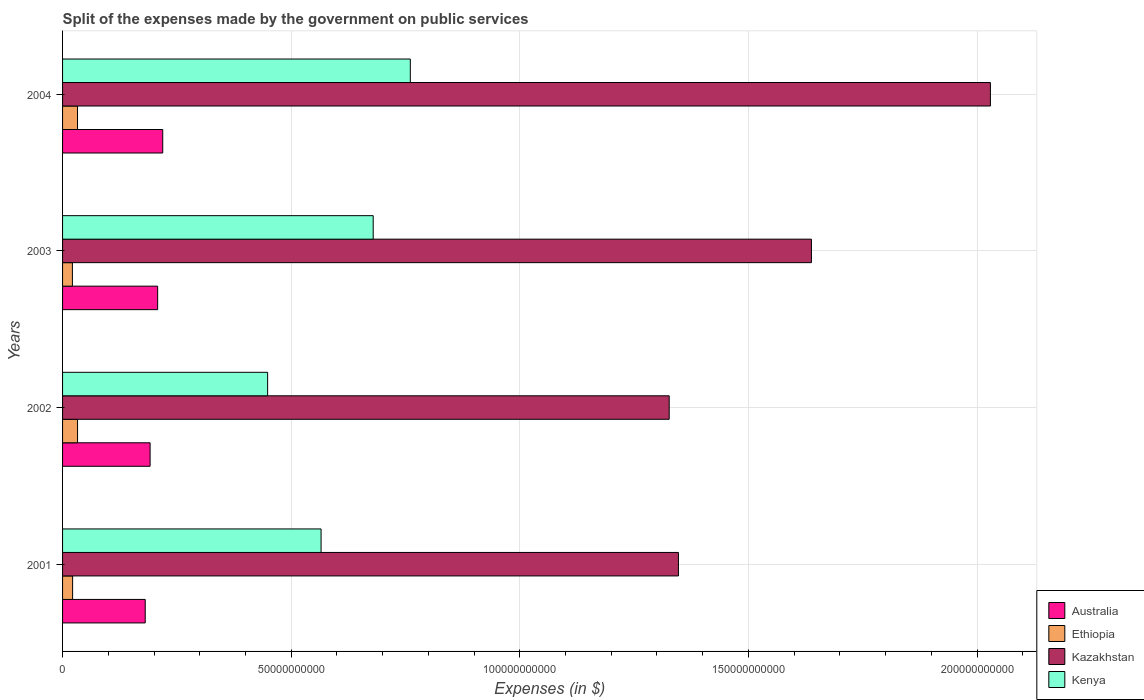How many different coloured bars are there?
Keep it short and to the point. 4. How many groups of bars are there?
Offer a very short reply. 4. Are the number of bars per tick equal to the number of legend labels?
Give a very brief answer. Yes. Are the number of bars on each tick of the Y-axis equal?
Offer a terse response. Yes. What is the expenses made by the government on public services in Australia in 2002?
Your answer should be very brief. 1.91e+1. Across all years, what is the maximum expenses made by the government on public services in Kazakhstan?
Ensure brevity in your answer.  2.03e+11. Across all years, what is the minimum expenses made by the government on public services in Kazakhstan?
Ensure brevity in your answer.  1.33e+11. In which year was the expenses made by the government on public services in Kazakhstan maximum?
Your answer should be very brief. 2004. In which year was the expenses made by the government on public services in Ethiopia minimum?
Your answer should be compact. 2003. What is the total expenses made by the government on public services in Ethiopia in the graph?
Offer a terse response. 1.09e+1. What is the difference between the expenses made by the government on public services in Kenya in 2001 and that in 2002?
Offer a terse response. 1.17e+1. What is the difference between the expenses made by the government on public services in Australia in 2003 and the expenses made by the government on public services in Kazakhstan in 2002?
Give a very brief answer. -1.12e+11. What is the average expenses made by the government on public services in Australia per year?
Provide a succinct answer. 2.00e+1. In the year 2001, what is the difference between the expenses made by the government on public services in Australia and expenses made by the government on public services in Kazakhstan?
Keep it short and to the point. -1.17e+11. What is the ratio of the expenses made by the government on public services in Ethiopia in 2003 to that in 2004?
Keep it short and to the point. 0.66. Is the expenses made by the government on public services in Ethiopia in 2001 less than that in 2003?
Keep it short and to the point. No. Is the difference between the expenses made by the government on public services in Australia in 2001 and 2003 greater than the difference between the expenses made by the government on public services in Kazakhstan in 2001 and 2003?
Your answer should be very brief. Yes. What is the difference between the highest and the second highest expenses made by the government on public services in Kenya?
Offer a terse response. 8.12e+09. What is the difference between the highest and the lowest expenses made by the government on public services in Australia?
Give a very brief answer. 3.83e+09. In how many years, is the expenses made by the government on public services in Australia greater than the average expenses made by the government on public services in Australia taken over all years?
Give a very brief answer. 2. Is the sum of the expenses made by the government on public services in Kazakhstan in 2002 and 2003 greater than the maximum expenses made by the government on public services in Ethiopia across all years?
Offer a very short reply. Yes. Is it the case that in every year, the sum of the expenses made by the government on public services in Australia and expenses made by the government on public services in Kazakhstan is greater than the sum of expenses made by the government on public services in Ethiopia and expenses made by the government on public services in Kenya?
Your answer should be compact. No. What does the 3rd bar from the top in 2004 represents?
Provide a short and direct response. Ethiopia. What does the 3rd bar from the bottom in 2004 represents?
Provide a succinct answer. Kazakhstan. How many bars are there?
Provide a short and direct response. 16. Are all the bars in the graph horizontal?
Ensure brevity in your answer.  Yes. How many years are there in the graph?
Provide a short and direct response. 4. Where does the legend appear in the graph?
Keep it short and to the point. Bottom right. What is the title of the graph?
Make the answer very short. Split of the expenses made by the government on public services. What is the label or title of the X-axis?
Make the answer very short. Expenses (in $). What is the Expenses (in $) in Australia in 2001?
Keep it short and to the point. 1.81e+1. What is the Expenses (in $) of Ethiopia in 2001?
Keep it short and to the point. 2.20e+09. What is the Expenses (in $) in Kazakhstan in 2001?
Ensure brevity in your answer.  1.35e+11. What is the Expenses (in $) in Kenya in 2001?
Offer a terse response. 5.65e+1. What is the Expenses (in $) of Australia in 2002?
Offer a terse response. 1.91e+1. What is the Expenses (in $) in Ethiopia in 2002?
Your response must be concise. 3.28e+09. What is the Expenses (in $) in Kazakhstan in 2002?
Your response must be concise. 1.33e+11. What is the Expenses (in $) of Kenya in 2002?
Your answer should be very brief. 4.49e+1. What is the Expenses (in $) in Australia in 2003?
Provide a short and direct response. 2.08e+1. What is the Expenses (in $) in Ethiopia in 2003?
Give a very brief answer. 2.15e+09. What is the Expenses (in $) of Kazakhstan in 2003?
Keep it short and to the point. 1.64e+11. What is the Expenses (in $) of Kenya in 2003?
Provide a succinct answer. 6.79e+1. What is the Expenses (in $) of Australia in 2004?
Provide a short and direct response. 2.19e+1. What is the Expenses (in $) in Ethiopia in 2004?
Make the answer very short. 3.27e+09. What is the Expenses (in $) in Kazakhstan in 2004?
Provide a succinct answer. 2.03e+11. What is the Expenses (in $) of Kenya in 2004?
Provide a short and direct response. 7.61e+1. Across all years, what is the maximum Expenses (in $) in Australia?
Provide a succinct answer. 2.19e+1. Across all years, what is the maximum Expenses (in $) of Ethiopia?
Give a very brief answer. 3.28e+09. Across all years, what is the maximum Expenses (in $) in Kazakhstan?
Offer a very short reply. 2.03e+11. Across all years, what is the maximum Expenses (in $) of Kenya?
Ensure brevity in your answer.  7.61e+1. Across all years, what is the minimum Expenses (in $) in Australia?
Make the answer very short. 1.81e+1. Across all years, what is the minimum Expenses (in $) in Ethiopia?
Make the answer very short. 2.15e+09. Across all years, what is the minimum Expenses (in $) in Kazakhstan?
Your response must be concise. 1.33e+11. Across all years, what is the minimum Expenses (in $) of Kenya?
Give a very brief answer. 4.49e+1. What is the total Expenses (in $) in Australia in the graph?
Provide a succinct answer. 7.99e+1. What is the total Expenses (in $) in Ethiopia in the graph?
Give a very brief answer. 1.09e+1. What is the total Expenses (in $) in Kazakhstan in the graph?
Provide a succinct answer. 6.34e+11. What is the total Expenses (in $) of Kenya in the graph?
Ensure brevity in your answer.  2.45e+11. What is the difference between the Expenses (in $) in Australia in 2001 and that in 2002?
Ensure brevity in your answer.  -1.06e+09. What is the difference between the Expenses (in $) in Ethiopia in 2001 and that in 2002?
Offer a very short reply. -1.08e+09. What is the difference between the Expenses (in $) in Kazakhstan in 2001 and that in 2002?
Ensure brevity in your answer.  2.02e+09. What is the difference between the Expenses (in $) in Kenya in 2001 and that in 2002?
Your answer should be compact. 1.17e+1. What is the difference between the Expenses (in $) of Australia in 2001 and that in 2003?
Keep it short and to the point. -2.72e+09. What is the difference between the Expenses (in $) in Ethiopia in 2001 and that in 2003?
Give a very brief answer. 4.57e+07. What is the difference between the Expenses (in $) in Kazakhstan in 2001 and that in 2003?
Provide a succinct answer. -2.91e+1. What is the difference between the Expenses (in $) in Kenya in 2001 and that in 2003?
Your response must be concise. -1.14e+1. What is the difference between the Expenses (in $) in Australia in 2001 and that in 2004?
Your answer should be compact. -3.83e+09. What is the difference between the Expenses (in $) of Ethiopia in 2001 and that in 2004?
Your answer should be very brief. -1.07e+09. What is the difference between the Expenses (in $) in Kazakhstan in 2001 and that in 2004?
Ensure brevity in your answer.  -6.82e+1. What is the difference between the Expenses (in $) in Kenya in 2001 and that in 2004?
Make the answer very short. -1.95e+1. What is the difference between the Expenses (in $) in Australia in 2002 and that in 2003?
Your response must be concise. -1.66e+09. What is the difference between the Expenses (in $) of Ethiopia in 2002 and that in 2003?
Keep it short and to the point. 1.13e+09. What is the difference between the Expenses (in $) of Kazakhstan in 2002 and that in 2003?
Give a very brief answer. -3.11e+1. What is the difference between the Expenses (in $) of Kenya in 2002 and that in 2003?
Offer a terse response. -2.31e+1. What is the difference between the Expenses (in $) of Australia in 2002 and that in 2004?
Offer a terse response. -2.77e+09. What is the difference between the Expenses (in $) in Ethiopia in 2002 and that in 2004?
Provide a succinct answer. 8.70e+06. What is the difference between the Expenses (in $) of Kazakhstan in 2002 and that in 2004?
Your answer should be compact. -7.03e+1. What is the difference between the Expenses (in $) of Kenya in 2002 and that in 2004?
Your response must be concise. -3.12e+1. What is the difference between the Expenses (in $) in Australia in 2003 and that in 2004?
Provide a short and direct response. -1.11e+09. What is the difference between the Expenses (in $) in Ethiopia in 2003 and that in 2004?
Provide a succinct answer. -1.12e+09. What is the difference between the Expenses (in $) of Kazakhstan in 2003 and that in 2004?
Your answer should be compact. -3.91e+1. What is the difference between the Expenses (in $) of Kenya in 2003 and that in 2004?
Provide a short and direct response. -8.12e+09. What is the difference between the Expenses (in $) of Australia in 2001 and the Expenses (in $) of Ethiopia in 2002?
Provide a short and direct response. 1.48e+1. What is the difference between the Expenses (in $) in Australia in 2001 and the Expenses (in $) in Kazakhstan in 2002?
Your response must be concise. -1.15e+11. What is the difference between the Expenses (in $) in Australia in 2001 and the Expenses (in $) in Kenya in 2002?
Provide a succinct answer. -2.68e+1. What is the difference between the Expenses (in $) of Ethiopia in 2001 and the Expenses (in $) of Kazakhstan in 2002?
Offer a terse response. -1.30e+11. What is the difference between the Expenses (in $) of Ethiopia in 2001 and the Expenses (in $) of Kenya in 2002?
Offer a terse response. -4.27e+1. What is the difference between the Expenses (in $) in Kazakhstan in 2001 and the Expenses (in $) in Kenya in 2002?
Provide a succinct answer. 8.98e+1. What is the difference between the Expenses (in $) of Australia in 2001 and the Expenses (in $) of Ethiopia in 2003?
Keep it short and to the point. 1.59e+1. What is the difference between the Expenses (in $) of Australia in 2001 and the Expenses (in $) of Kazakhstan in 2003?
Keep it short and to the point. -1.46e+11. What is the difference between the Expenses (in $) of Australia in 2001 and the Expenses (in $) of Kenya in 2003?
Offer a terse response. -4.99e+1. What is the difference between the Expenses (in $) in Ethiopia in 2001 and the Expenses (in $) in Kazakhstan in 2003?
Your answer should be very brief. -1.62e+11. What is the difference between the Expenses (in $) in Ethiopia in 2001 and the Expenses (in $) in Kenya in 2003?
Your answer should be compact. -6.57e+1. What is the difference between the Expenses (in $) in Kazakhstan in 2001 and the Expenses (in $) in Kenya in 2003?
Make the answer very short. 6.68e+1. What is the difference between the Expenses (in $) in Australia in 2001 and the Expenses (in $) in Ethiopia in 2004?
Offer a terse response. 1.48e+1. What is the difference between the Expenses (in $) in Australia in 2001 and the Expenses (in $) in Kazakhstan in 2004?
Ensure brevity in your answer.  -1.85e+11. What is the difference between the Expenses (in $) in Australia in 2001 and the Expenses (in $) in Kenya in 2004?
Keep it short and to the point. -5.80e+1. What is the difference between the Expenses (in $) of Ethiopia in 2001 and the Expenses (in $) of Kazakhstan in 2004?
Your response must be concise. -2.01e+11. What is the difference between the Expenses (in $) in Ethiopia in 2001 and the Expenses (in $) in Kenya in 2004?
Keep it short and to the point. -7.39e+1. What is the difference between the Expenses (in $) in Kazakhstan in 2001 and the Expenses (in $) in Kenya in 2004?
Keep it short and to the point. 5.86e+1. What is the difference between the Expenses (in $) in Australia in 2002 and the Expenses (in $) in Ethiopia in 2003?
Ensure brevity in your answer.  1.70e+1. What is the difference between the Expenses (in $) of Australia in 2002 and the Expenses (in $) of Kazakhstan in 2003?
Your answer should be very brief. -1.45e+11. What is the difference between the Expenses (in $) in Australia in 2002 and the Expenses (in $) in Kenya in 2003?
Provide a short and direct response. -4.88e+1. What is the difference between the Expenses (in $) of Ethiopia in 2002 and the Expenses (in $) of Kazakhstan in 2003?
Offer a very short reply. -1.61e+11. What is the difference between the Expenses (in $) in Ethiopia in 2002 and the Expenses (in $) in Kenya in 2003?
Offer a terse response. -6.47e+1. What is the difference between the Expenses (in $) in Kazakhstan in 2002 and the Expenses (in $) in Kenya in 2003?
Ensure brevity in your answer.  6.47e+1. What is the difference between the Expenses (in $) in Australia in 2002 and the Expenses (in $) in Ethiopia in 2004?
Offer a terse response. 1.59e+1. What is the difference between the Expenses (in $) in Australia in 2002 and the Expenses (in $) in Kazakhstan in 2004?
Offer a very short reply. -1.84e+11. What is the difference between the Expenses (in $) of Australia in 2002 and the Expenses (in $) of Kenya in 2004?
Offer a very short reply. -5.69e+1. What is the difference between the Expenses (in $) of Ethiopia in 2002 and the Expenses (in $) of Kazakhstan in 2004?
Your response must be concise. -2.00e+11. What is the difference between the Expenses (in $) of Ethiopia in 2002 and the Expenses (in $) of Kenya in 2004?
Provide a short and direct response. -7.28e+1. What is the difference between the Expenses (in $) in Kazakhstan in 2002 and the Expenses (in $) in Kenya in 2004?
Provide a succinct answer. 5.66e+1. What is the difference between the Expenses (in $) of Australia in 2003 and the Expenses (in $) of Ethiopia in 2004?
Offer a very short reply. 1.75e+1. What is the difference between the Expenses (in $) of Australia in 2003 and the Expenses (in $) of Kazakhstan in 2004?
Offer a very short reply. -1.82e+11. What is the difference between the Expenses (in $) of Australia in 2003 and the Expenses (in $) of Kenya in 2004?
Offer a terse response. -5.53e+1. What is the difference between the Expenses (in $) of Ethiopia in 2003 and the Expenses (in $) of Kazakhstan in 2004?
Ensure brevity in your answer.  -2.01e+11. What is the difference between the Expenses (in $) of Ethiopia in 2003 and the Expenses (in $) of Kenya in 2004?
Ensure brevity in your answer.  -7.39e+1. What is the difference between the Expenses (in $) of Kazakhstan in 2003 and the Expenses (in $) of Kenya in 2004?
Make the answer very short. 8.77e+1. What is the average Expenses (in $) of Australia per year?
Offer a very short reply. 2.00e+1. What is the average Expenses (in $) in Ethiopia per year?
Offer a terse response. 2.72e+09. What is the average Expenses (in $) of Kazakhstan per year?
Your response must be concise. 1.59e+11. What is the average Expenses (in $) in Kenya per year?
Ensure brevity in your answer.  6.13e+1. In the year 2001, what is the difference between the Expenses (in $) in Australia and Expenses (in $) in Ethiopia?
Offer a very short reply. 1.59e+1. In the year 2001, what is the difference between the Expenses (in $) of Australia and Expenses (in $) of Kazakhstan?
Provide a succinct answer. -1.17e+11. In the year 2001, what is the difference between the Expenses (in $) of Australia and Expenses (in $) of Kenya?
Your answer should be very brief. -3.85e+1. In the year 2001, what is the difference between the Expenses (in $) of Ethiopia and Expenses (in $) of Kazakhstan?
Offer a terse response. -1.33e+11. In the year 2001, what is the difference between the Expenses (in $) in Ethiopia and Expenses (in $) in Kenya?
Offer a terse response. -5.43e+1. In the year 2001, what is the difference between the Expenses (in $) in Kazakhstan and Expenses (in $) in Kenya?
Ensure brevity in your answer.  7.82e+1. In the year 2002, what is the difference between the Expenses (in $) in Australia and Expenses (in $) in Ethiopia?
Give a very brief answer. 1.59e+1. In the year 2002, what is the difference between the Expenses (in $) in Australia and Expenses (in $) in Kazakhstan?
Give a very brief answer. -1.14e+11. In the year 2002, what is the difference between the Expenses (in $) of Australia and Expenses (in $) of Kenya?
Provide a succinct answer. -2.57e+1. In the year 2002, what is the difference between the Expenses (in $) of Ethiopia and Expenses (in $) of Kazakhstan?
Offer a very short reply. -1.29e+11. In the year 2002, what is the difference between the Expenses (in $) in Ethiopia and Expenses (in $) in Kenya?
Keep it short and to the point. -4.16e+1. In the year 2002, what is the difference between the Expenses (in $) in Kazakhstan and Expenses (in $) in Kenya?
Your response must be concise. 8.78e+1. In the year 2003, what is the difference between the Expenses (in $) of Australia and Expenses (in $) of Ethiopia?
Your answer should be very brief. 1.86e+1. In the year 2003, what is the difference between the Expenses (in $) of Australia and Expenses (in $) of Kazakhstan?
Give a very brief answer. -1.43e+11. In the year 2003, what is the difference between the Expenses (in $) in Australia and Expenses (in $) in Kenya?
Provide a short and direct response. -4.71e+1. In the year 2003, what is the difference between the Expenses (in $) of Ethiopia and Expenses (in $) of Kazakhstan?
Offer a very short reply. -1.62e+11. In the year 2003, what is the difference between the Expenses (in $) of Ethiopia and Expenses (in $) of Kenya?
Your answer should be compact. -6.58e+1. In the year 2003, what is the difference between the Expenses (in $) in Kazakhstan and Expenses (in $) in Kenya?
Ensure brevity in your answer.  9.58e+1. In the year 2004, what is the difference between the Expenses (in $) of Australia and Expenses (in $) of Ethiopia?
Your response must be concise. 1.86e+1. In the year 2004, what is the difference between the Expenses (in $) in Australia and Expenses (in $) in Kazakhstan?
Make the answer very short. -1.81e+11. In the year 2004, what is the difference between the Expenses (in $) of Australia and Expenses (in $) of Kenya?
Provide a short and direct response. -5.41e+1. In the year 2004, what is the difference between the Expenses (in $) in Ethiopia and Expenses (in $) in Kazakhstan?
Provide a succinct answer. -2.00e+11. In the year 2004, what is the difference between the Expenses (in $) in Ethiopia and Expenses (in $) in Kenya?
Make the answer very short. -7.28e+1. In the year 2004, what is the difference between the Expenses (in $) of Kazakhstan and Expenses (in $) of Kenya?
Your response must be concise. 1.27e+11. What is the ratio of the Expenses (in $) in Ethiopia in 2001 to that in 2002?
Offer a terse response. 0.67. What is the ratio of the Expenses (in $) in Kazakhstan in 2001 to that in 2002?
Offer a terse response. 1.02. What is the ratio of the Expenses (in $) of Kenya in 2001 to that in 2002?
Your answer should be very brief. 1.26. What is the ratio of the Expenses (in $) of Australia in 2001 to that in 2003?
Give a very brief answer. 0.87. What is the ratio of the Expenses (in $) in Ethiopia in 2001 to that in 2003?
Keep it short and to the point. 1.02. What is the ratio of the Expenses (in $) in Kazakhstan in 2001 to that in 2003?
Give a very brief answer. 0.82. What is the ratio of the Expenses (in $) of Kenya in 2001 to that in 2003?
Provide a succinct answer. 0.83. What is the ratio of the Expenses (in $) of Australia in 2001 to that in 2004?
Your answer should be compact. 0.83. What is the ratio of the Expenses (in $) of Ethiopia in 2001 to that in 2004?
Your answer should be very brief. 0.67. What is the ratio of the Expenses (in $) in Kazakhstan in 2001 to that in 2004?
Your answer should be compact. 0.66. What is the ratio of the Expenses (in $) in Kenya in 2001 to that in 2004?
Give a very brief answer. 0.74. What is the ratio of the Expenses (in $) of Australia in 2002 to that in 2003?
Ensure brevity in your answer.  0.92. What is the ratio of the Expenses (in $) in Ethiopia in 2002 to that in 2003?
Give a very brief answer. 1.52. What is the ratio of the Expenses (in $) of Kazakhstan in 2002 to that in 2003?
Provide a succinct answer. 0.81. What is the ratio of the Expenses (in $) in Kenya in 2002 to that in 2003?
Ensure brevity in your answer.  0.66. What is the ratio of the Expenses (in $) in Australia in 2002 to that in 2004?
Offer a terse response. 0.87. What is the ratio of the Expenses (in $) of Kazakhstan in 2002 to that in 2004?
Offer a very short reply. 0.65. What is the ratio of the Expenses (in $) of Kenya in 2002 to that in 2004?
Your answer should be very brief. 0.59. What is the ratio of the Expenses (in $) in Australia in 2003 to that in 2004?
Ensure brevity in your answer.  0.95. What is the ratio of the Expenses (in $) in Ethiopia in 2003 to that in 2004?
Ensure brevity in your answer.  0.66. What is the ratio of the Expenses (in $) of Kazakhstan in 2003 to that in 2004?
Give a very brief answer. 0.81. What is the ratio of the Expenses (in $) in Kenya in 2003 to that in 2004?
Your response must be concise. 0.89. What is the difference between the highest and the second highest Expenses (in $) of Australia?
Make the answer very short. 1.11e+09. What is the difference between the highest and the second highest Expenses (in $) in Ethiopia?
Ensure brevity in your answer.  8.70e+06. What is the difference between the highest and the second highest Expenses (in $) in Kazakhstan?
Make the answer very short. 3.91e+1. What is the difference between the highest and the second highest Expenses (in $) of Kenya?
Your answer should be very brief. 8.12e+09. What is the difference between the highest and the lowest Expenses (in $) in Australia?
Your answer should be compact. 3.83e+09. What is the difference between the highest and the lowest Expenses (in $) of Ethiopia?
Your answer should be compact. 1.13e+09. What is the difference between the highest and the lowest Expenses (in $) in Kazakhstan?
Offer a terse response. 7.03e+1. What is the difference between the highest and the lowest Expenses (in $) in Kenya?
Ensure brevity in your answer.  3.12e+1. 